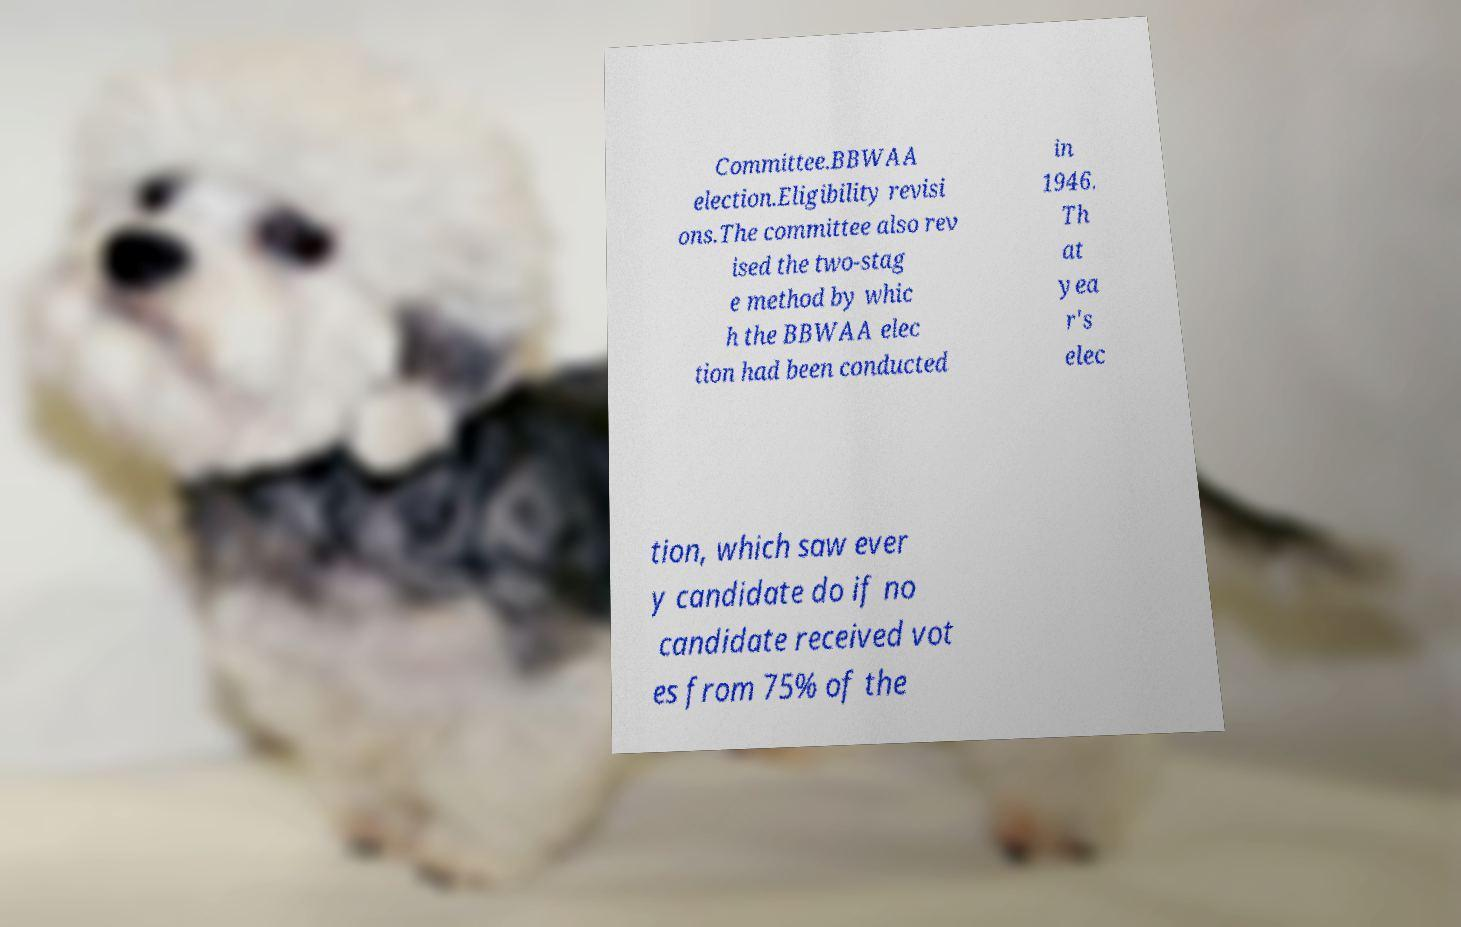Could you assist in decoding the text presented in this image and type it out clearly? Committee.BBWAA election.Eligibility revisi ons.The committee also rev ised the two-stag e method by whic h the BBWAA elec tion had been conducted in 1946. Th at yea r's elec tion, which saw ever y candidate do if no candidate received vot es from 75% of the 